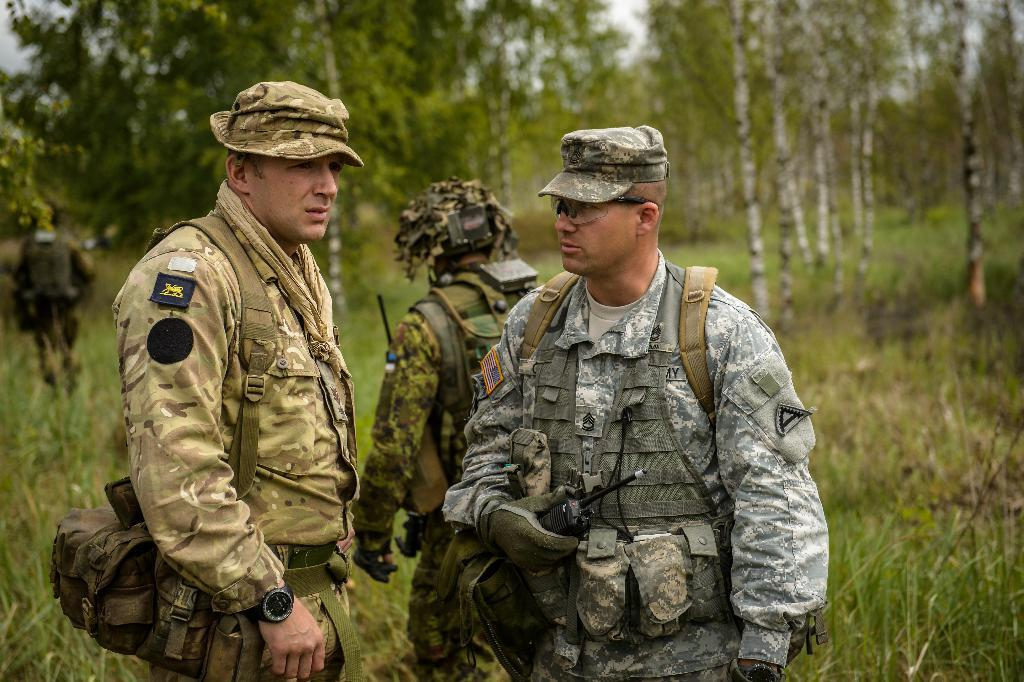How many people are present in the image? There are people in the image, but the exact number is not specified. What are some people doing in the image? Some people are holding objects and wearing bags or caps. What can be seen in the background of the image? There is grass and trees in the background of the image. How much oatmeal is being consumed by the people in the image? There is no oatmeal present in the image, so it cannot be determined how much is being consumed. How many ears are visible on the people in the image? The number of ears visible on the people in the image is not specified, and it is not possible to determine this from the provided facts. 